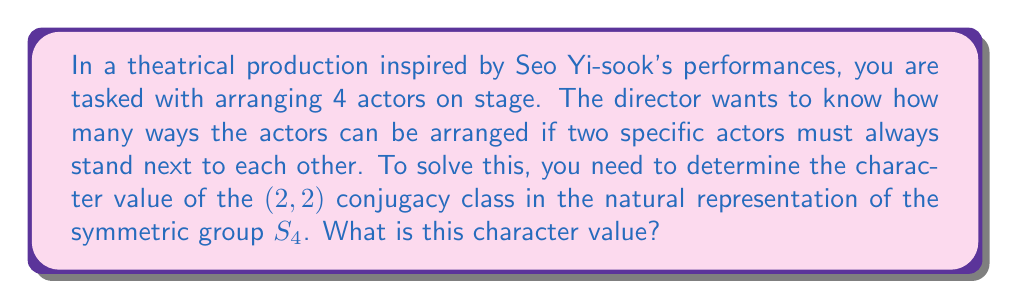Solve this math problem. Let's approach this step-by-step:

1) The natural representation of $S_4$ acts on a 4-dimensional vector space with basis $\{e_1, e_2, e_3, e_4\}$, where each basis vector corresponds to an actor's position.

2) The (2,2) conjugacy class in $S_4$ consists of permutations with cycle type (2,2), e.g., $(12)(34)$.

3) To find the character value, we need to calculate the trace of the matrix representing this permutation in the natural representation.

4) The permutation $(12)(34)$ can be represented by the matrix:

   $$\begin{pmatrix}
   0 & 1 & 0 & 0 \\
   1 & 0 & 0 & 0 \\
   0 & 0 & 0 & 1 \\
   0 & 0 & 1 & 0
   \end{pmatrix}$$

5) The trace of this matrix is the sum of its diagonal elements:

   $\text{Tr} = 0 + 0 + 0 + 0 = 0$

6) Therefore, the character value of the (2,2) conjugacy class in the natural representation of $S_4$ is 0.

7) In terms of the theatrical arrangement, this means that when we fix two actors next to each other (creating a (2,2) cycle type), there are no arrangements where all actors remain in their original positions, which is why the trace (and thus the character value) is 0.
Answer: 0 